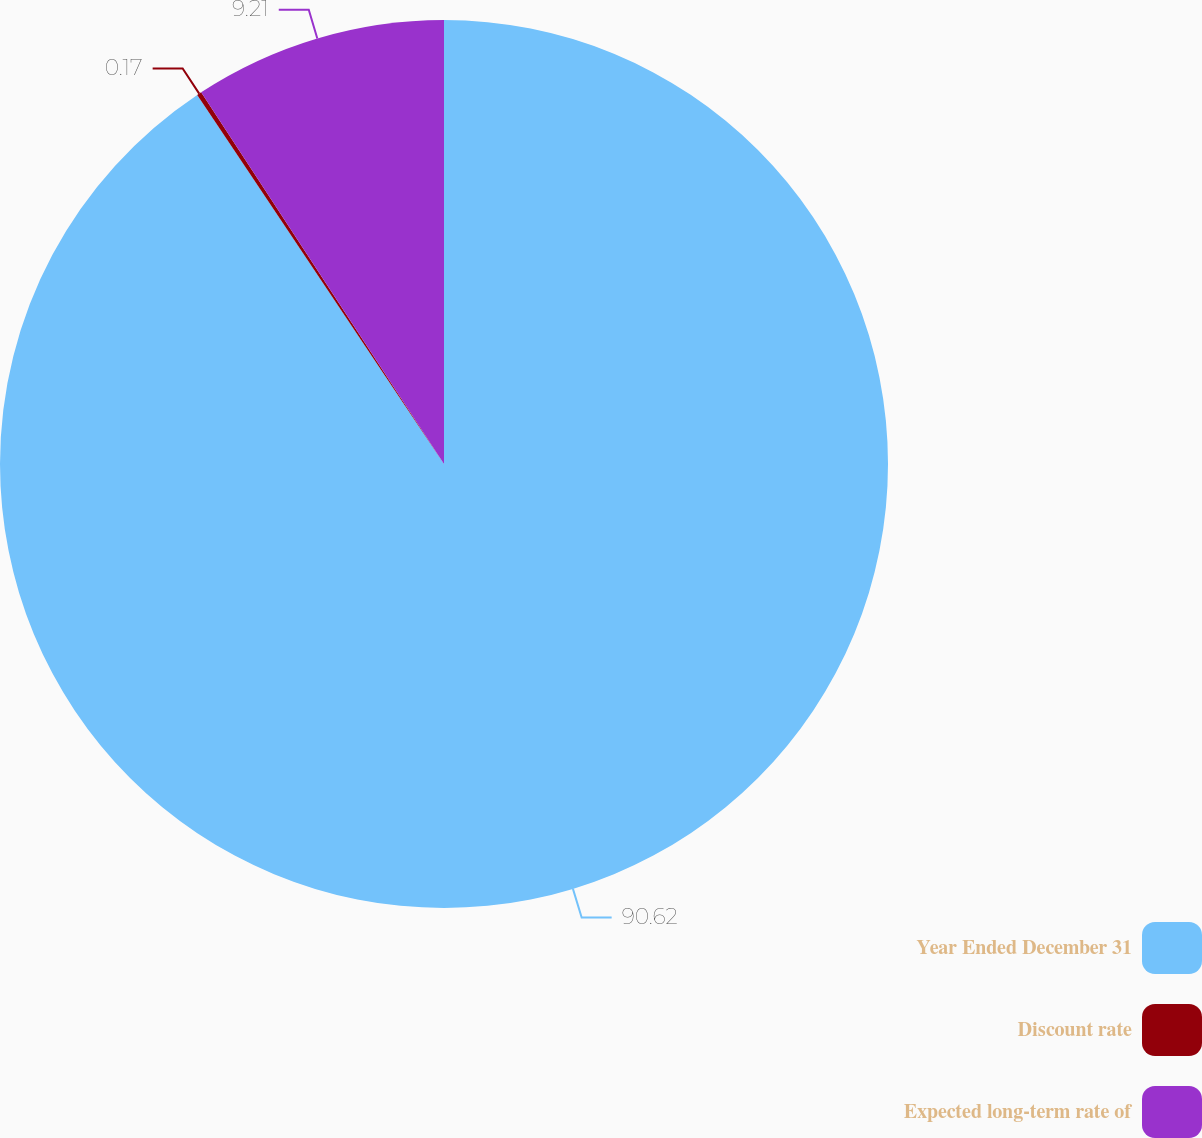Convert chart to OTSL. <chart><loc_0><loc_0><loc_500><loc_500><pie_chart><fcel>Year Ended December 31<fcel>Discount rate<fcel>Expected long-term rate of<nl><fcel>90.62%<fcel>0.17%<fcel>9.21%<nl></chart> 